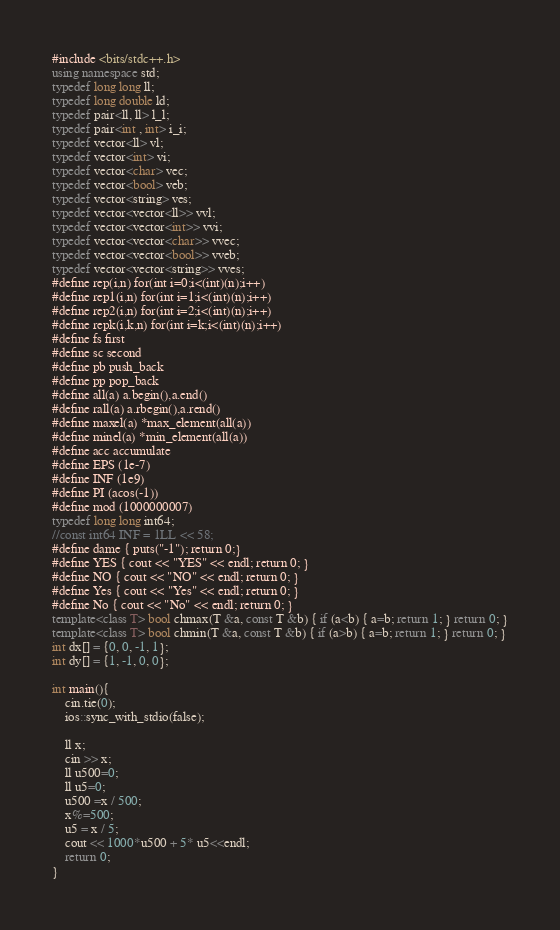Convert code to text. <code><loc_0><loc_0><loc_500><loc_500><_C++_>#include <bits/stdc++.h>
using namespace std;
typedef long long ll;
typedef long double ld;
typedef pair<ll, ll> l_l;
typedef pair<int , int> i_i;
typedef vector<ll> vl;
typedef vector<int> vi;
typedef vector<char> vec;
typedef vector<bool> veb;
typedef vector<string> ves;
typedef vector<vector<ll>> vvl;
typedef vector<vector<int>> vvi;
typedef vector<vector<char>> vvec;
typedef vector<vector<bool>> vveb;
typedef vector<vector<string>> vves;
#define rep(i,n) for(int i=0;i<(int)(n);i++)
#define rep1(i,n) for(int i=1;i<(int)(n);i++)
#define rep2(i,n) for(int i=2;i<(int)(n);i++)
#define repk(i,k,n) for(int i=k;i<(int)(n);i++)
#define fs first
#define sc second
#define pb push_back
#define pp pop_back
#define all(a) a.begin(),a.end()
#define rall(a) a.rbegin(),a.rend()
#define maxel(a) *max_element(all(a))
#define minel(a) *min_element(all(a))
#define acc accumulate
#define EPS (1e-7)
#define INF (1e9)
#define PI (acos(-1))
#define mod (1000000007)
typedef long long int64;
//const int64 INF = 1LL << 58;
#define dame { puts("-1"); return 0;}
#define YES { cout << "YES" << endl; return 0; }
#define NO { cout << "NO" << endl; return 0; }
#define Yes { cout << "Yes" << endl; return 0; }
#define No { cout << "No" << endl; return 0; }
template<class T> bool chmax(T &a, const T &b) { if (a<b) { a=b; return 1; } return 0; }
template<class T> bool chmin(T &a, const T &b) { if (a>b) { a=b; return 1; } return 0; }
int dx[] = {0, 0, -1, 1};
int dy[] = {1, -1, 0, 0};

int main(){
	cin.tie(0);
	ios::sync_with_stdio(false);

  	ll x;
  	cin >> x;
  	ll u500=0;
  	ll u5=0;
  	u500 =x / 500;
  	x%=500;
  	u5 = x / 5;
  	cout << 1000*u500 + 5* u5<<endl;
  	return 0;
}</code> 